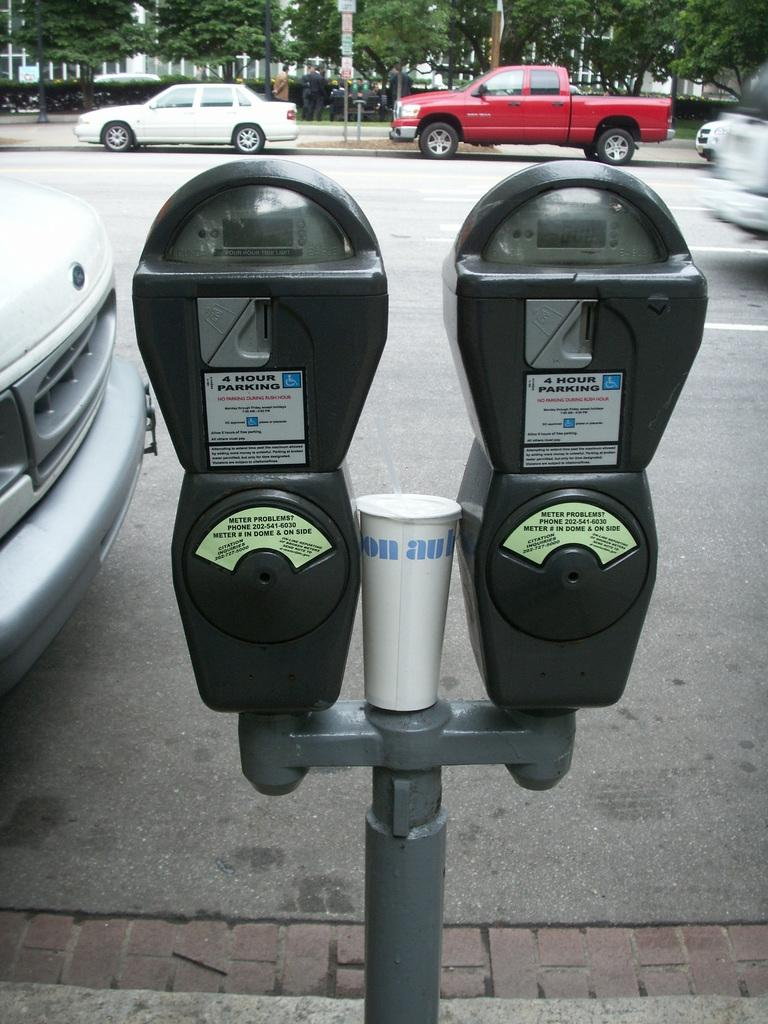<image>
Share a concise interpretation of the image provided. A double parking meter for four hour parking. 